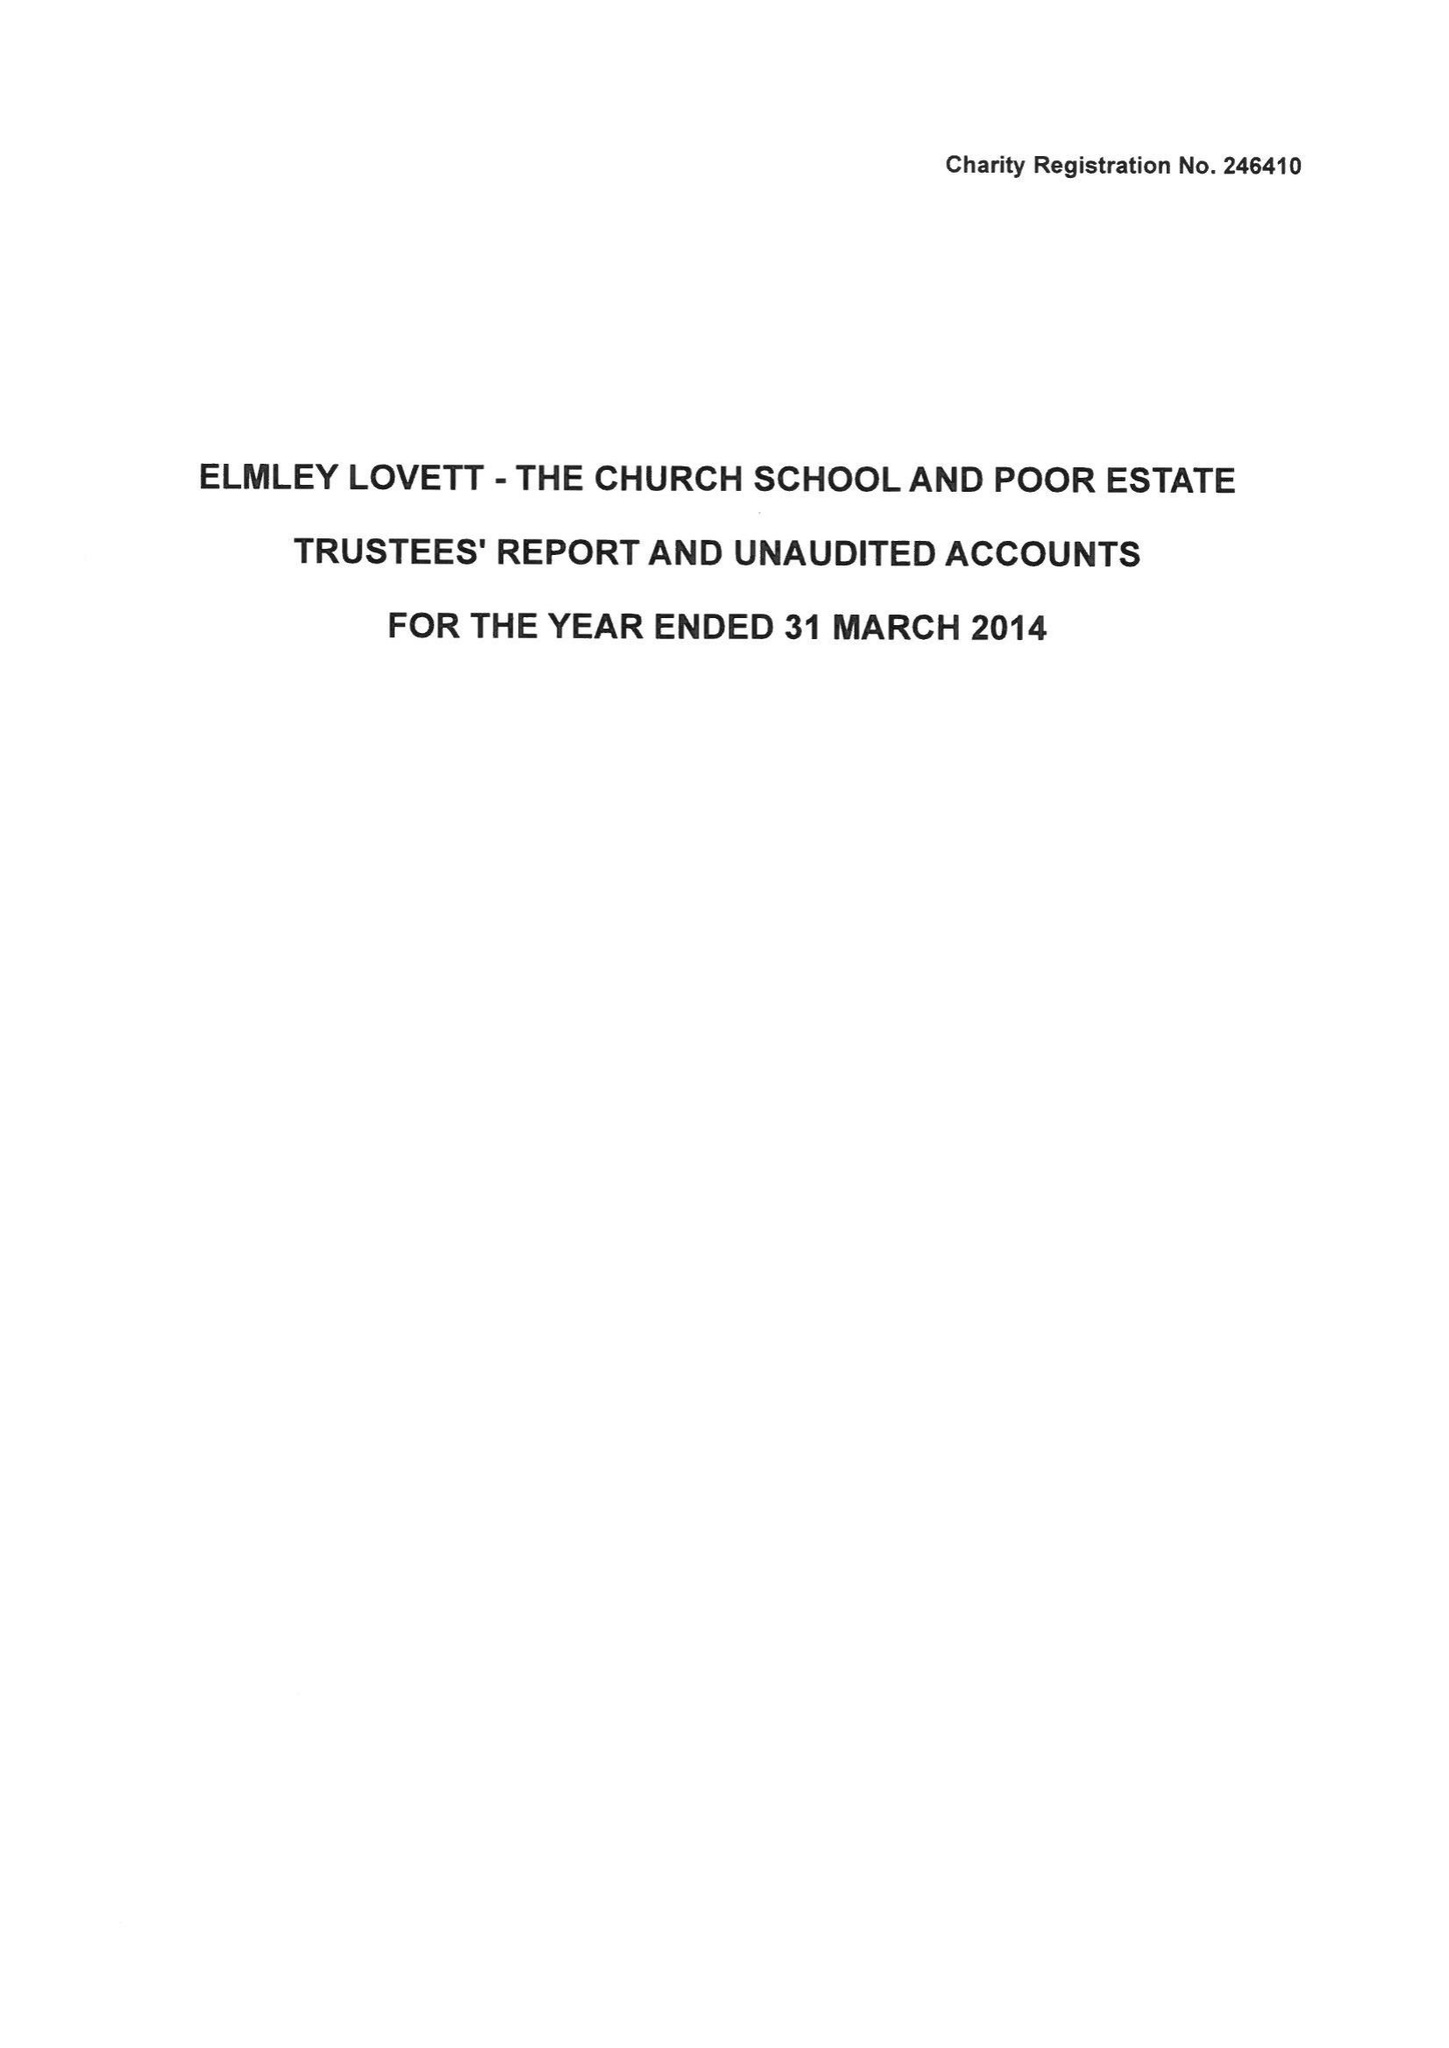What is the value for the address__street_line?
Answer the question using a single word or phrase. None 